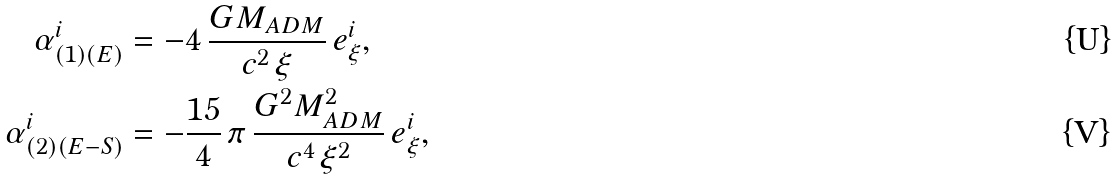Convert formula to latex. <formula><loc_0><loc_0><loc_500><loc_500>\alpha ^ { i } _ { ( 1 ) ( E ) } & = - 4 \, \frac { G M _ { A D M } } { c ^ { 2 } \, \xi } \, e ^ { i } _ { \xi } , \\ \alpha ^ { i } _ { ( 2 ) ( E - S ) } & = - \frac { 1 5 } { 4 } \, \pi \, \frac { G ^ { 2 } M ^ { 2 } _ { A D M } } { c ^ { 4 } \, \xi ^ { 2 } } \, e ^ { i } _ { \xi } ,</formula> 